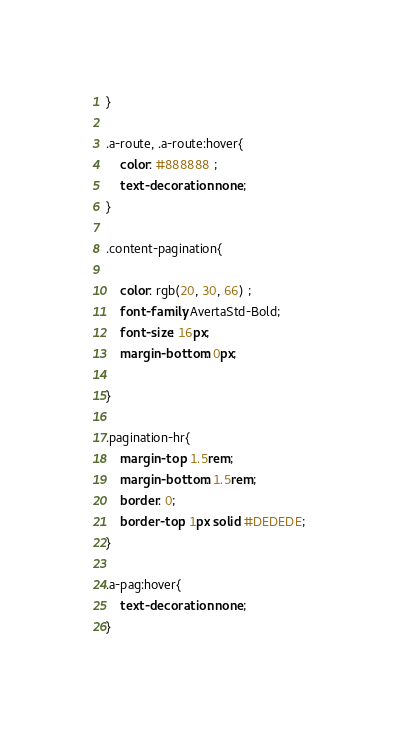Convert code to text. <code><loc_0><loc_0><loc_500><loc_500><_CSS_>}

.a-route, .a-route:hover{
    color: #888888 ;
    text-decoration: none;
}

.content-pagination{

    color: rgb(20, 30, 66) ;
    font-family: AvertaStd-Bold;
    font-size: 16px;
    margin-bottom: 0px;

}

.pagination-hr{
    margin-top: 1.5rem;
    margin-bottom: 1.5rem;
    border: 0;
    border-top: 1px solid #DEDEDE;
}

.a-pag:hover{
    text-decoration: none;
}</code> 